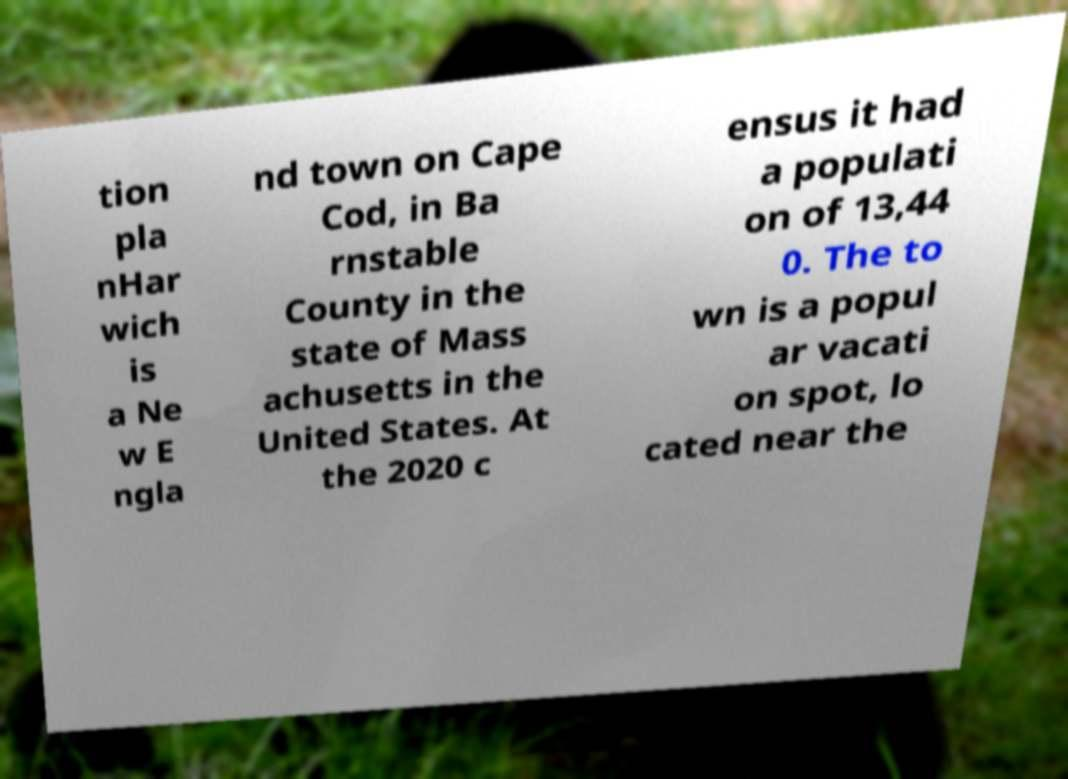Please identify and transcribe the text found in this image. tion pla nHar wich is a Ne w E ngla nd town on Cape Cod, in Ba rnstable County in the state of Mass achusetts in the United States. At the 2020 c ensus it had a populati on of 13,44 0. The to wn is a popul ar vacati on spot, lo cated near the 